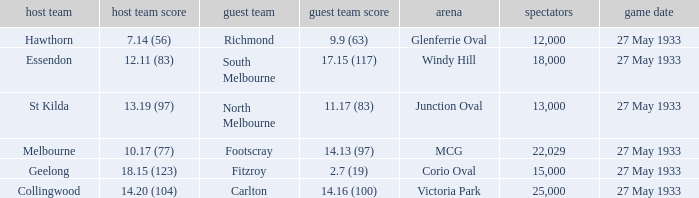In the match where the home team scored 14.20 (104), how many attendees were in the crowd? 25000.0. 